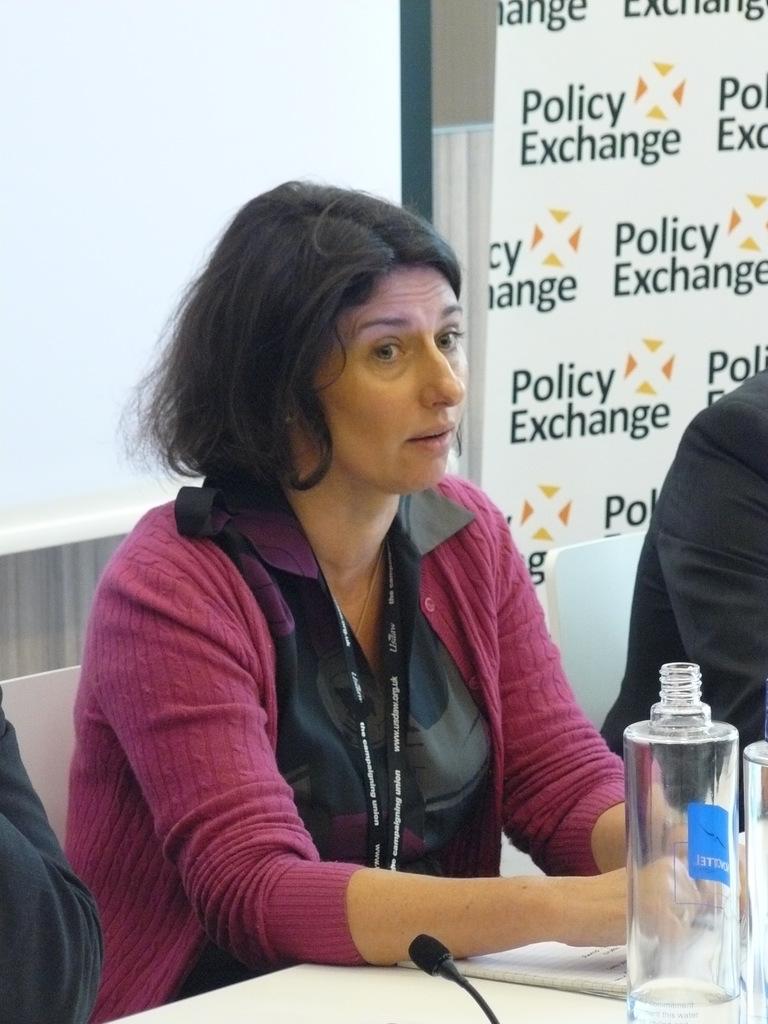What colour is her cardigan?
Your response must be concise. Answering does not require reading text in the image. 